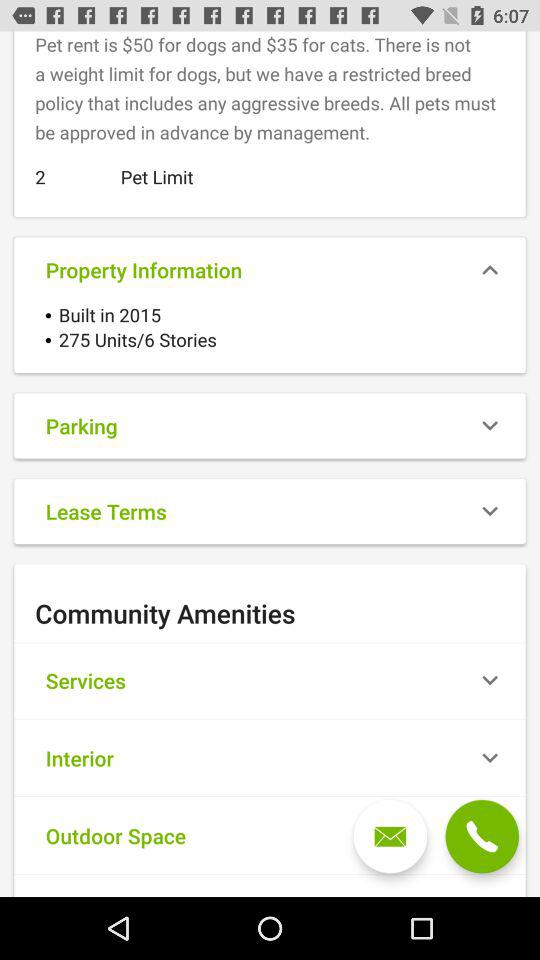Which pet has a rent of $50? The pet that has a rent of $50 is a dog. 